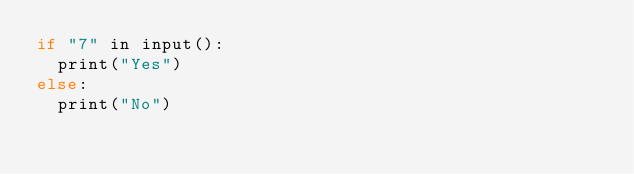Convert code to text. <code><loc_0><loc_0><loc_500><loc_500><_C_>if "7" in input():
	print("Yes")
else:
	print("No")</code> 